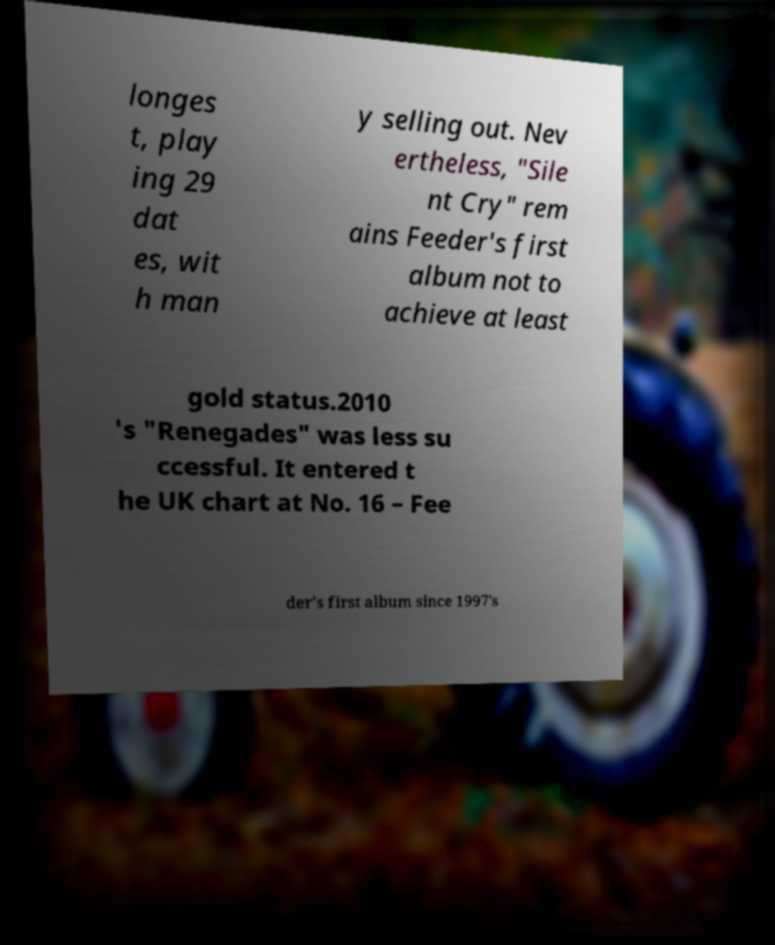What messages or text are displayed in this image? I need them in a readable, typed format. longes t, play ing 29 dat es, wit h man y selling out. Nev ertheless, "Sile nt Cry" rem ains Feeder's first album not to achieve at least gold status.2010 's "Renegades" was less su ccessful. It entered t he UK chart at No. 16 – Fee der's first album since 1997's 